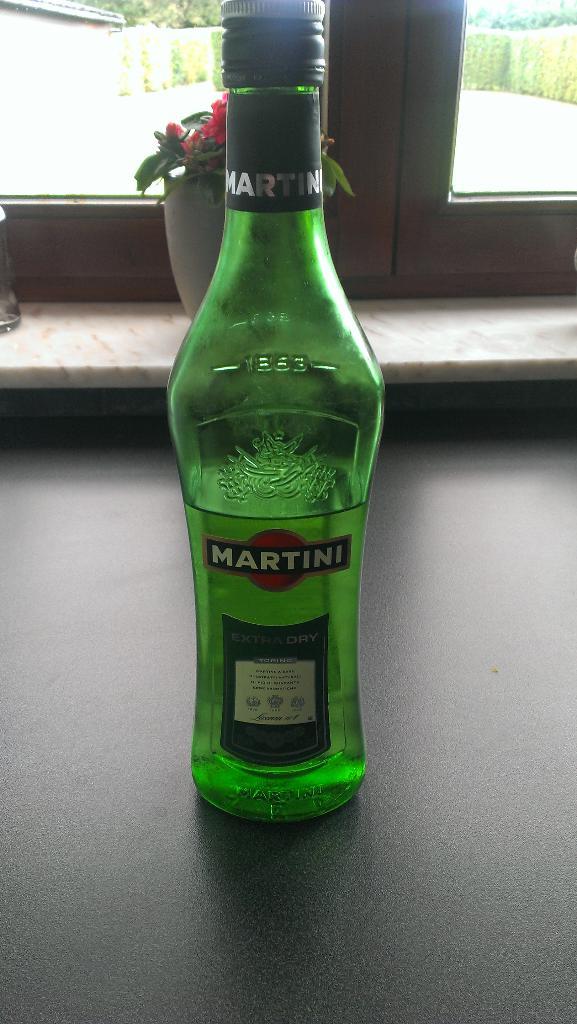What´s the name of the drink?
Your answer should be very brief. Martini. 